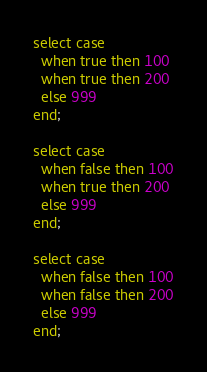<code> <loc_0><loc_0><loc_500><loc_500><_SQL_>select case 
  when true then 100
  when true then 200
  else 999
end;

select case 
  when false then 100
  when true then 200
  else 999
end;

select case 
  when false then 100
  when false then 200
  else 999
end;

</code> 